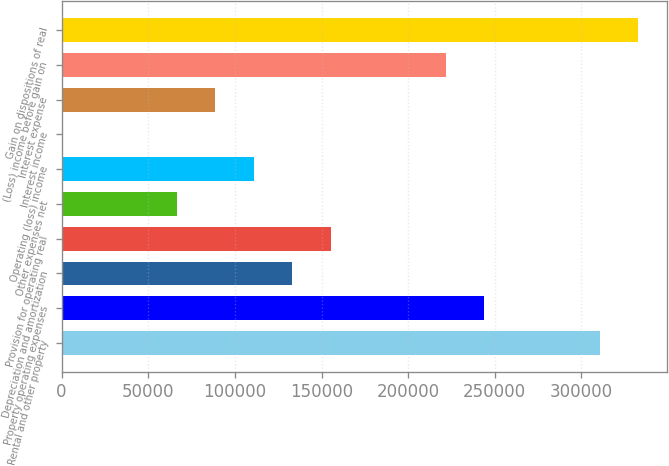Convert chart to OTSL. <chart><loc_0><loc_0><loc_500><loc_500><bar_chart><fcel>Rental and other property<fcel>Property operating expenses<fcel>Depreciation and amortization<fcel>Provision for operating real<fcel>Other expenses net<fcel>Operating (loss) income<fcel>Interest income<fcel>Interest expense<fcel>(Loss) income before gain on<fcel>Gain on dispositions of real<nl><fcel>310465<fcel>243961<fcel>133121<fcel>155289<fcel>66616.3<fcel>110952<fcel>112<fcel>88784.4<fcel>221793<fcel>332634<nl></chart> 